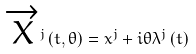Convert formula to latex. <formula><loc_0><loc_0><loc_500><loc_500>\overrightarrow { X } ^ { j } \left ( t , \theta \right ) = x ^ { j } + i \theta \lambda ^ { j } \left ( t \right )</formula> 